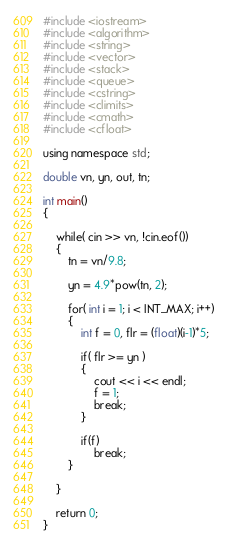<code> <loc_0><loc_0><loc_500><loc_500><_C++_>#include <iostream>
#include <algorithm>
#include <string>
#include <vector>
#include <stack>
#include <queue>
#include <cstring>
#include <climits>
#include <cmath>
#include <cfloat>

using namespace std;

double vn, yn, out, tn;

int main()
{
	
	while( cin >> vn, !cin.eof())
	{
		tn = vn/9.8;
		
		yn = 4.9*pow(tn, 2);
		
		for( int i = 1; i < INT_MAX; i++)
		{
			int f = 0, flr = (float)(i-1)*5;
			
			if( flr >= yn )
			{
				cout << i << endl;
				f = 1;
				break;
			}
			
			if(f)
				break;
		}
		
	}
	
	return 0;
}</code> 